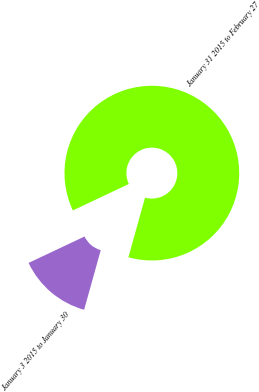Convert chart to OTSL. <chart><loc_0><loc_0><loc_500><loc_500><pie_chart><fcel>January 3 2015 to January 30<fcel>January 31 2015 to February 27<nl><fcel>13.65%<fcel>86.35%<nl></chart> 